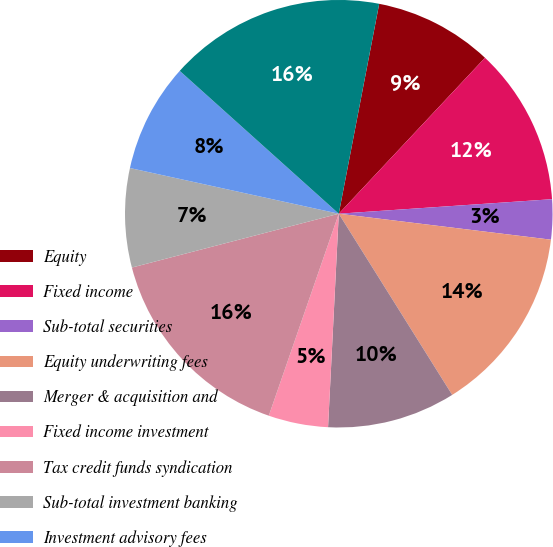Convert chart. <chart><loc_0><loc_0><loc_500><loc_500><pie_chart><fcel>Equity<fcel>Fixed income<fcel>Sub-total securities<fcel>Equity underwriting fees<fcel>Merger & acquisition and<fcel>Fixed income investment<fcel>Tax credit funds syndication<fcel>Sub-total investment banking<fcel>Investment advisory fees<fcel>Net trading profit<nl><fcel>8.96%<fcel>11.93%<fcel>3.02%<fcel>14.16%<fcel>9.7%<fcel>4.51%<fcel>15.64%<fcel>7.48%<fcel>8.22%<fcel>16.38%<nl></chart> 